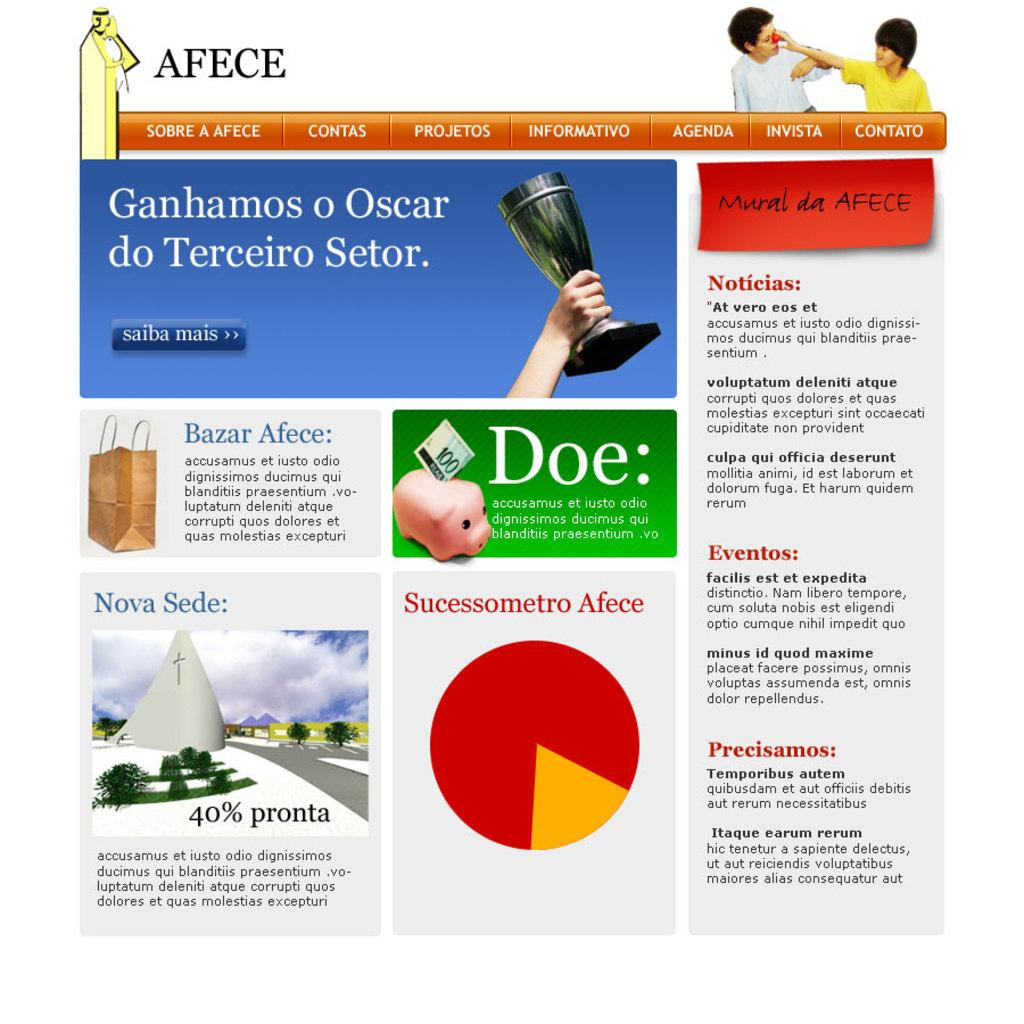What type of document is shown in the image? The image is of a brochure. What information does the brochure provide? The brochure mentions many different sectors of a website. What type of mountain is visible in the background of the brochure? There is no mountain visible in the image, as it is a brochure about a website. What color is the cap worn by the person in the brochure? There is no person wearing a cap in the brochure, as it is focused on a website's sectors. 